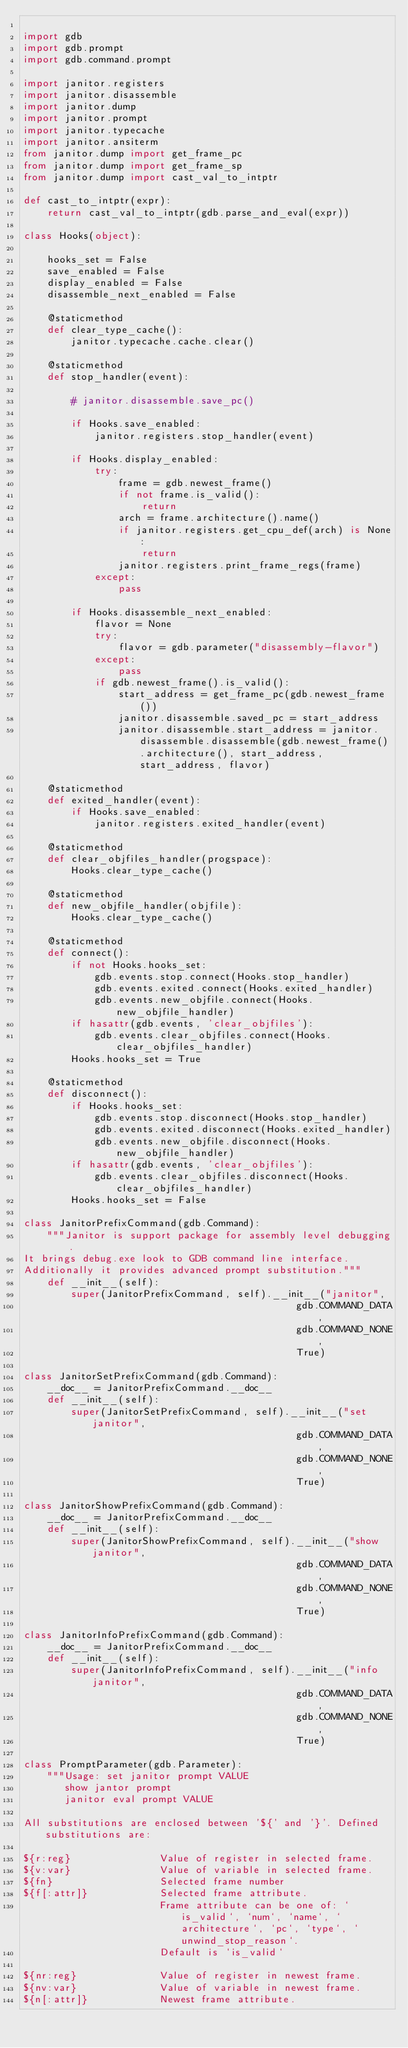<code> <loc_0><loc_0><loc_500><loc_500><_Python_>
import gdb
import gdb.prompt
import gdb.command.prompt

import janitor.registers
import janitor.disassemble
import janitor.dump
import janitor.prompt
import janitor.typecache
import janitor.ansiterm
from janitor.dump import get_frame_pc
from janitor.dump import get_frame_sp
from janitor.dump import cast_val_to_intptr

def cast_to_intptr(expr):
    return cast_val_to_intptr(gdb.parse_and_eval(expr))

class Hooks(object):
    
    hooks_set = False
    save_enabled = False
    display_enabled = False
    disassemble_next_enabled = False
    
    @staticmethod
    def clear_type_cache():
        janitor.typecache.cache.clear()

    @staticmethod
    def stop_handler(event):
        
        # janitor.disassemble.save_pc()
        
        if Hooks.save_enabled:
            janitor.registers.stop_handler(event)
        
        if Hooks.display_enabled:
            try:
                frame = gdb.newest_frame()
                if not frame.is_valid():
                    return
                arch = frame.architecture().name()
                if janitor.registers.get_cpu_def(arch) is None:
                    return
                janitor.registers.print_frame_regs(frame)
            except:
                pass
        
        if Hooks.disassemble_next_enabled:
            flavor = None
            try:
                flavor = gdb.parameter("disassembly-flavor")
            except:
                pass
            if gdb.newest_frame().is_valid():
                start_address = get_frame_pc(gdb.newest_frame())
                janitor.disassemble.saved_pc = start_address
                janitor.disassemble.start_address = janitor.disassemble.disassemble(gdb.newest_frame().architecture(), start_address, start_address, flavor)

    @staticmethod
    def exited_handler(event):
        if Hooks.save_enabled:
            janitor.registers.exited_handler(event)
    
    @staticmethod
    def clear_objfiles_handler(progspace):
        Hooks.clear_type_cache()

    @staticmethod
    def new_objfile_handler(objfile):
        Hooks.clear_type_cache()

    @staticmethod
    def connect():
        if not Hooks.hooks_set:
            gdb.events.stop.connect(Hooks.stop_handler)
            gdb.events.exited.connect(Hooks.exited_handler)
            gdb.events.new_objfile.connect(Hooks.new_objfile_handler)
        if hasattr(gdb.events, 'clear_objfiles'):
            gdb.events.clear_objfiles.connect(Hooks.clear_objfiles_handler)
        Hooks.hooks_set = True

    @staticmethod
    def disconnect():
        if Hooks.hooks_set:
            gdb.events.stop.disconnect(Hooks.stop_handler)
            gdb.events.exited.disconnect(Hooks.exited_handler)
            gdb.events.new_objfile.disconnect(Hooks.new_objfile_handler)
        if hasattr(gdb.events, 'clear_objfiles'):
            gdb.events.clear_objfiles.disconnect(Hooks.clear_objfiles_handler)
        Hooks.hooks_set = False

class JanitorPrefixCommand(gdb.Command):
    """Janitor is support package for assembly level debugging.
It brings debug.exe look to GDB command line interface.
Additionally it provides advanced prompt substitution."""
    def __init__(self):
        super(JanitorPrefixCommand, self).__init__("janitor",
                                              gdb.COMMAND_DATA,
                                              gdb.COMMAND_NONE,
                                              True)

class JanitorSetPrefixCommand(gdb.Command):
    __doc__ = JanitorPrefixCommand.__doc__
    def __init__(self):
        super(JanitorSetPrefixCommand, self).__init__("set janitor",
                                              gdb.COMMAND_DATA,
                                              gdb.COMMAND_NONE,
                                              True)

class JanitorShowPrefixCommand(gdb.Command):
    __doc__ = JanitorPrefixCommand.__doc__
    def __init__(self):
        super(JanitorShowPrefixCommand, self).__init__("show janitor",
                                              gdb.COMMAND_DATA,
                                              gdb.COMMAND_NONE,
                                              True)

class JanitorInfoPrefixCommand(gdb.Command):
    __doc__ = JanitorPrefixCommand.__doc__
    def __init__(self):
        super(JanitorInfoPrefixCommand, self).__init__("info janitor",
                                              gdb.COMMAND_DATA,
                                              gdb.COMMAND_NONE,
                                              True)

class PromptParameter(gdb.Parameter):
    """Usage: set janitor prompt VALUE
       show jantor prompt
       janitor eval prompt VALUE

All substitutions are enclosed between '${' and '}'. Defined substitutions are:

${r:reg}               Value of register in selected frame.
${v:var}               Value of variable in selected frame.
${fn}                  Selected frame number
${f[:attr]}            Selected frame attribute.
                       Frame attribute can be one of: `is_valid`, `num`, `name`, `architecture`, `pc`, `type`, `unwind_stop_reason`.
                       Default is `is_valid`

${nr:reg}              Value of register in newest frame.
${nv:var}              Value of variable in newest frame.
${n[:attr]}            Newest frame attribute.
</code> 